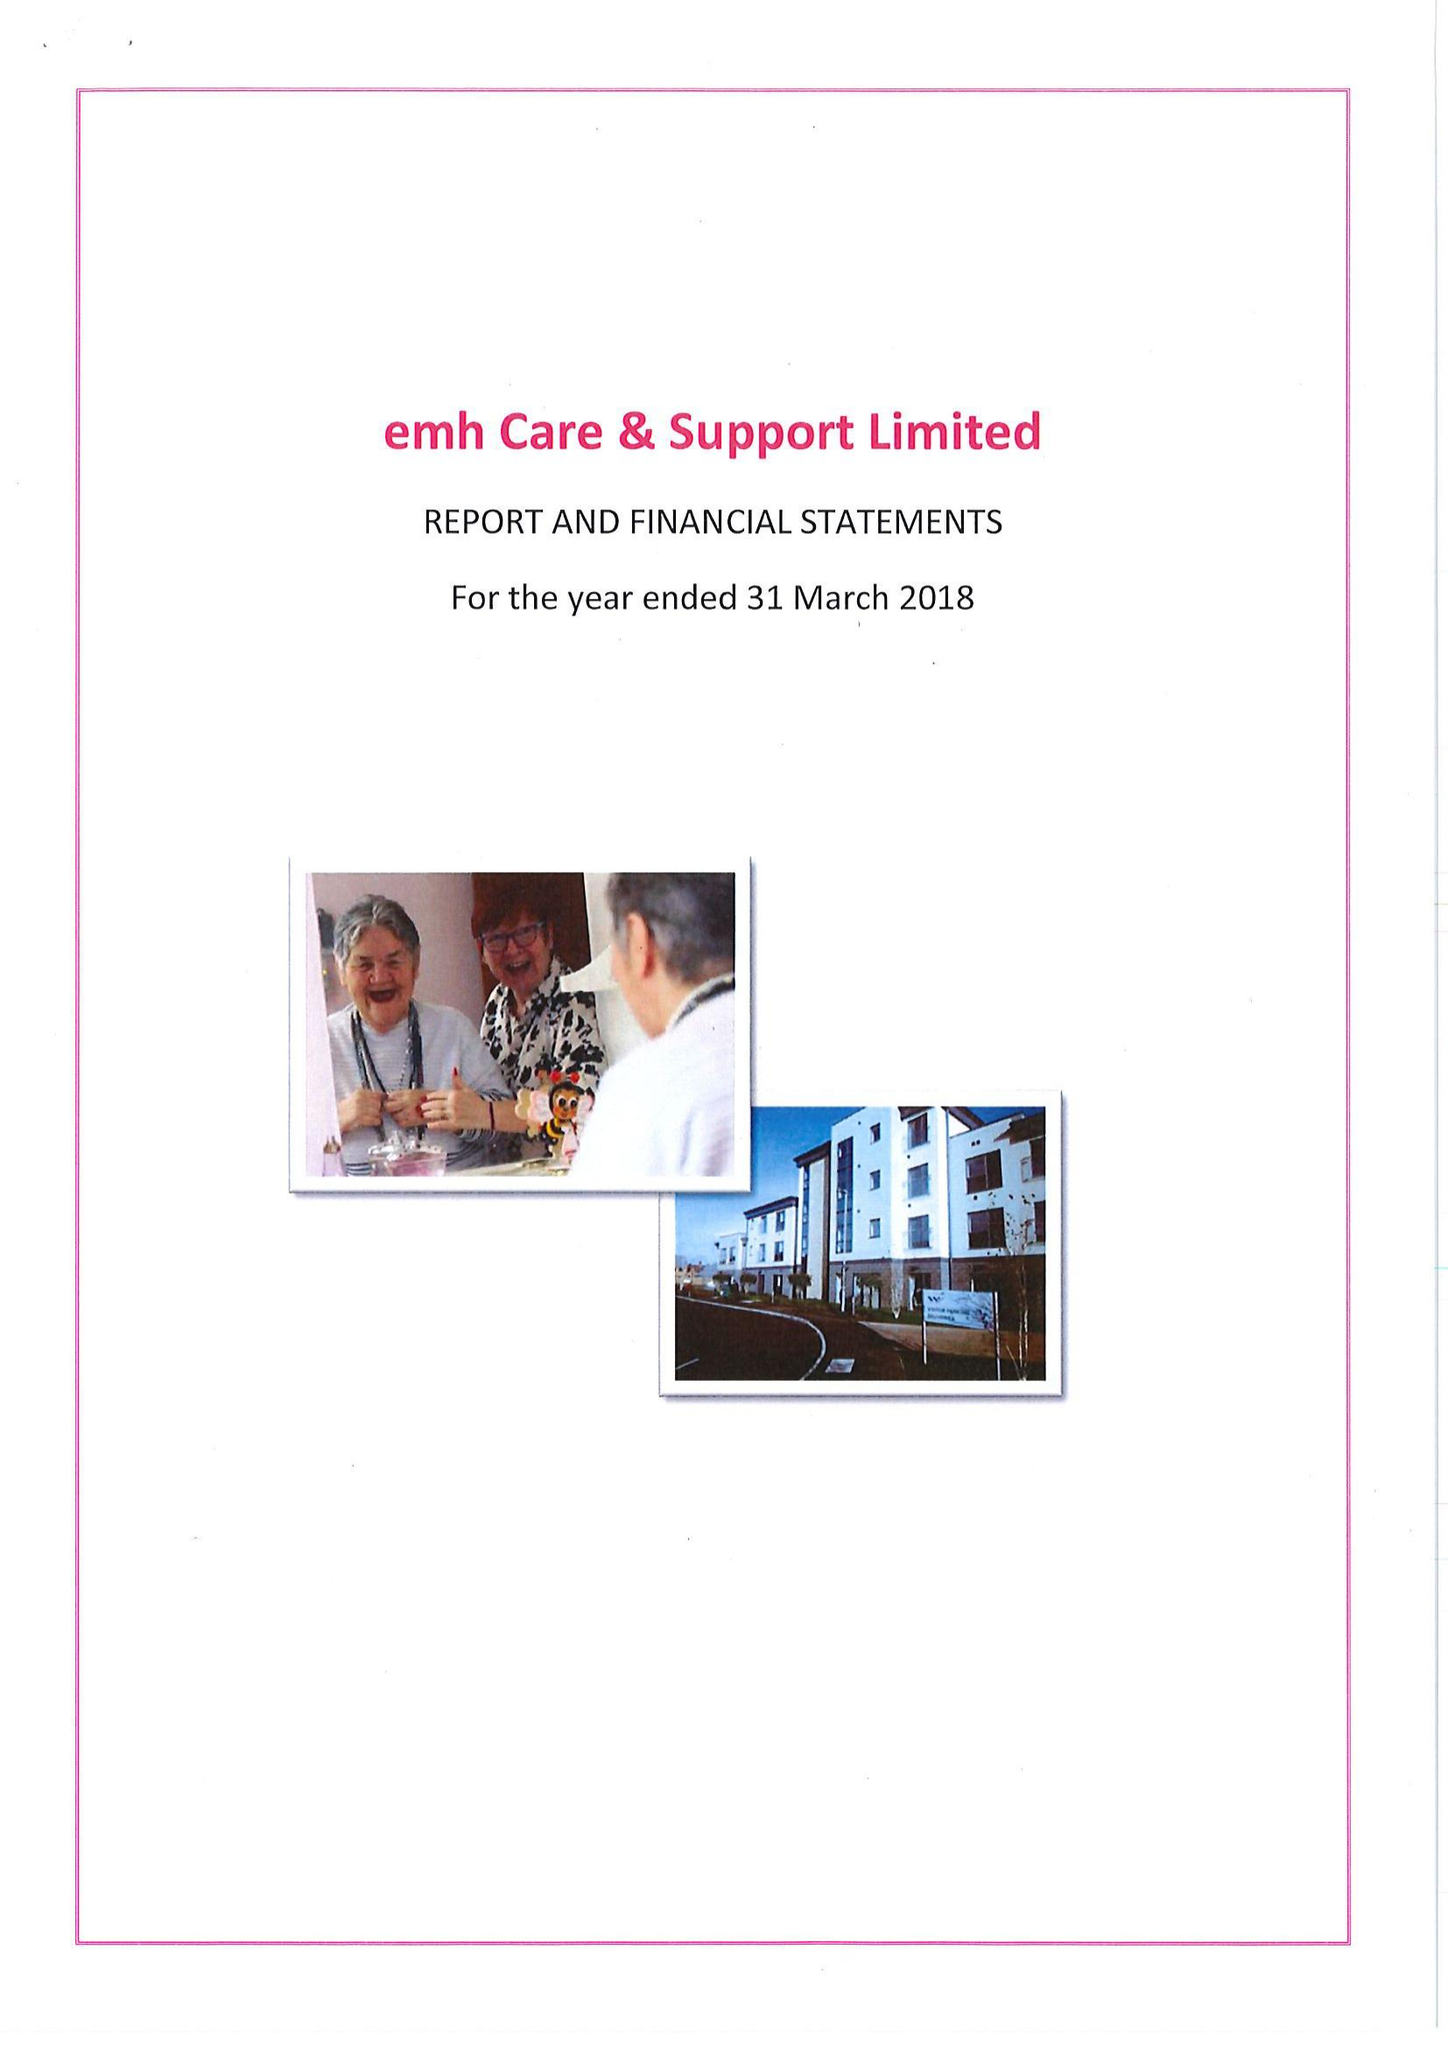What is the value for the charity_name?
Answer the question using a single word or phrase. Enable Care and Home Support Ltd. 